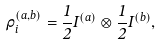Convert formula to latex. <formula><loc_0><loc_0><loc_500><loc_500>\rho _ { i } ^ { ( a , b ) } = \frac { 1 } { 2 } I ^ { ( a ) } \otimes \frac { 1 } { 2 } I ^ { ( b ) } ,</formula> 